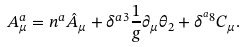<formula> <loc_0><loc_0><loc_500><loc_500>A _ { \mu } ^ { a } = n ^ { a } \hat { A } _ { \mu } + \delta ^ { a 3 } \frac { 1 } { g } \partial _ { \mu } \theta _ { 2 } + \delta ^ { ^ { a } 8 } C _ { \mu } .</formula> 